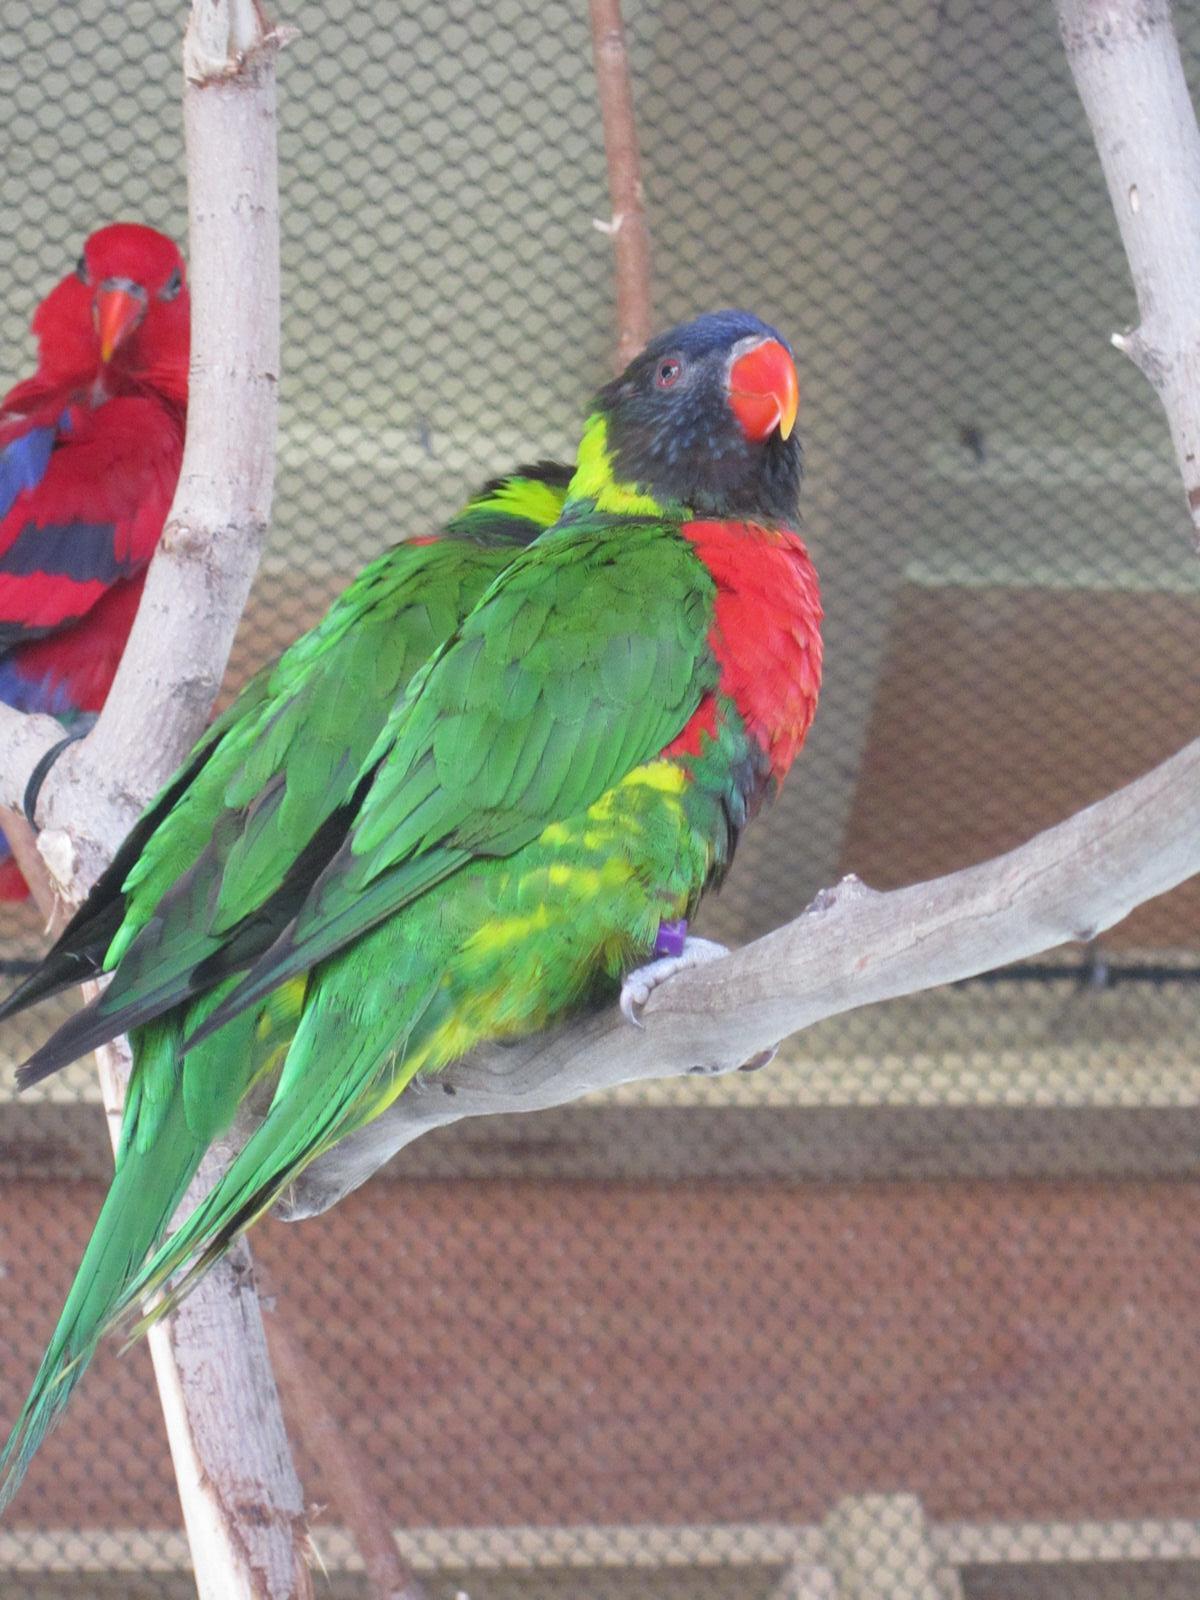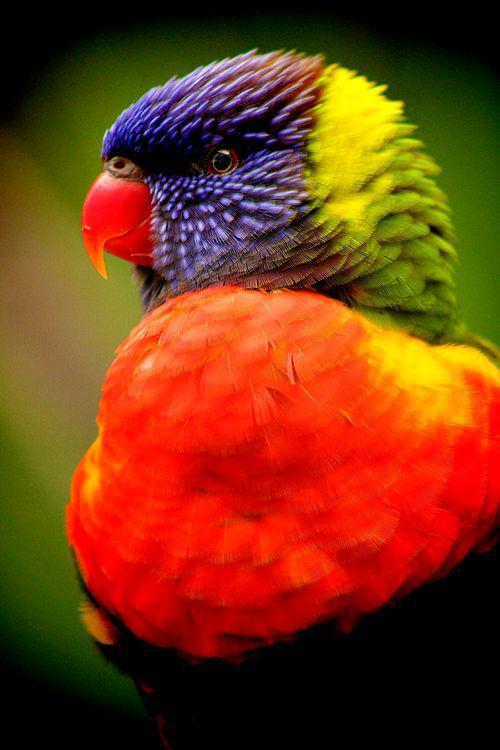The first image is the image on the left, the second image is the image on the right. Given the left and right images, does the statement "In at least one of the pictures, there are two birds that are both the same color." hold true? Answer yes or no. No. 